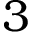Convert formula to latex. <formula><loc_0><loc_0><loc_500><loc_500>3</formula> 